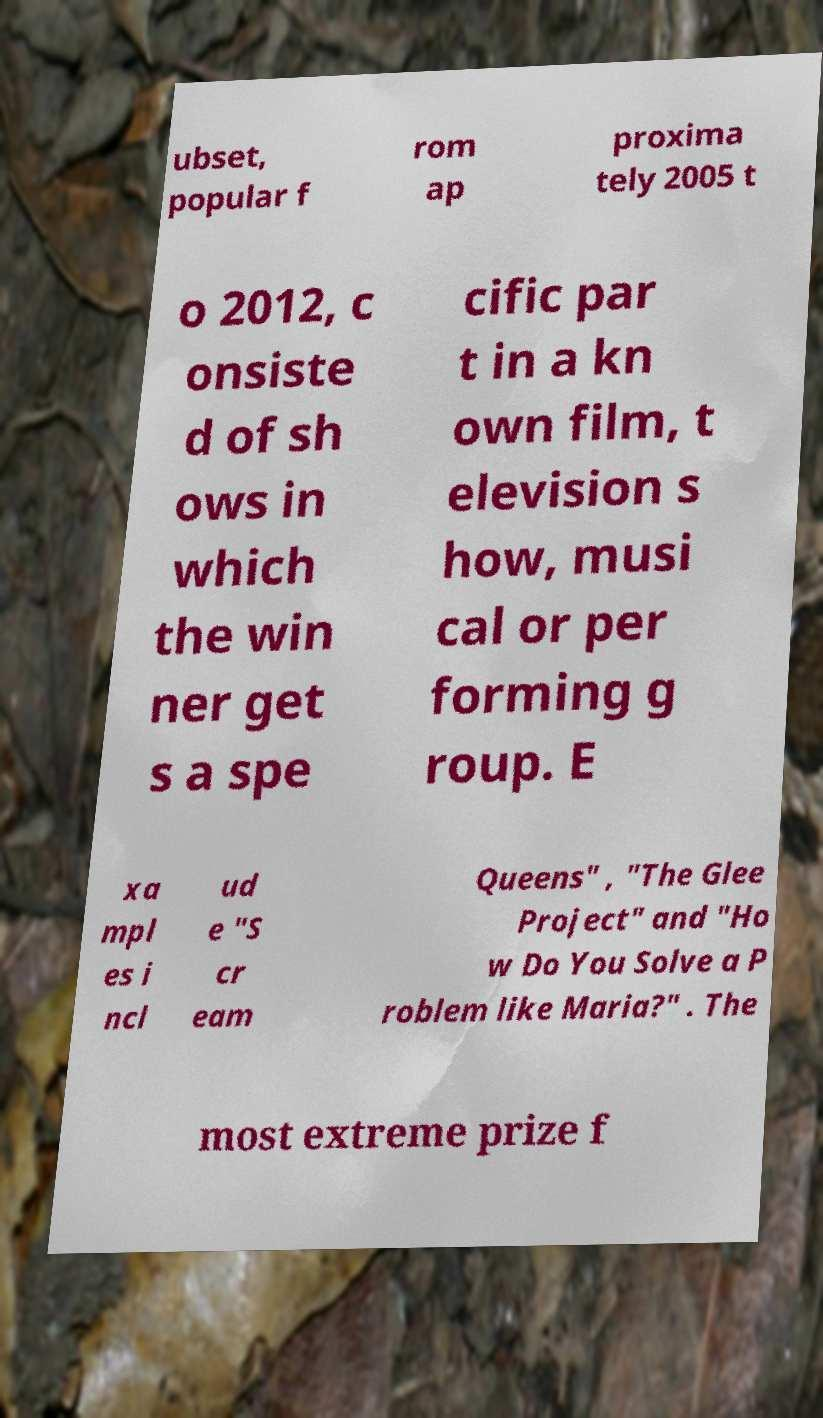Could you extract and type out the text from this image? ubset, popular f rom ap proxima tely 2005 t o 2012, c onsiste d of sh ows in which the win ner get s a spe cific par t in a kn own film, t elevision s how, musi cal or per forming g roup. E xa mpl es i ncl ud e "S cr eam Queens" , "The Glee Project" and "Ho w Do You Solve a P roblem like Maria?" . The most extreme prize f 